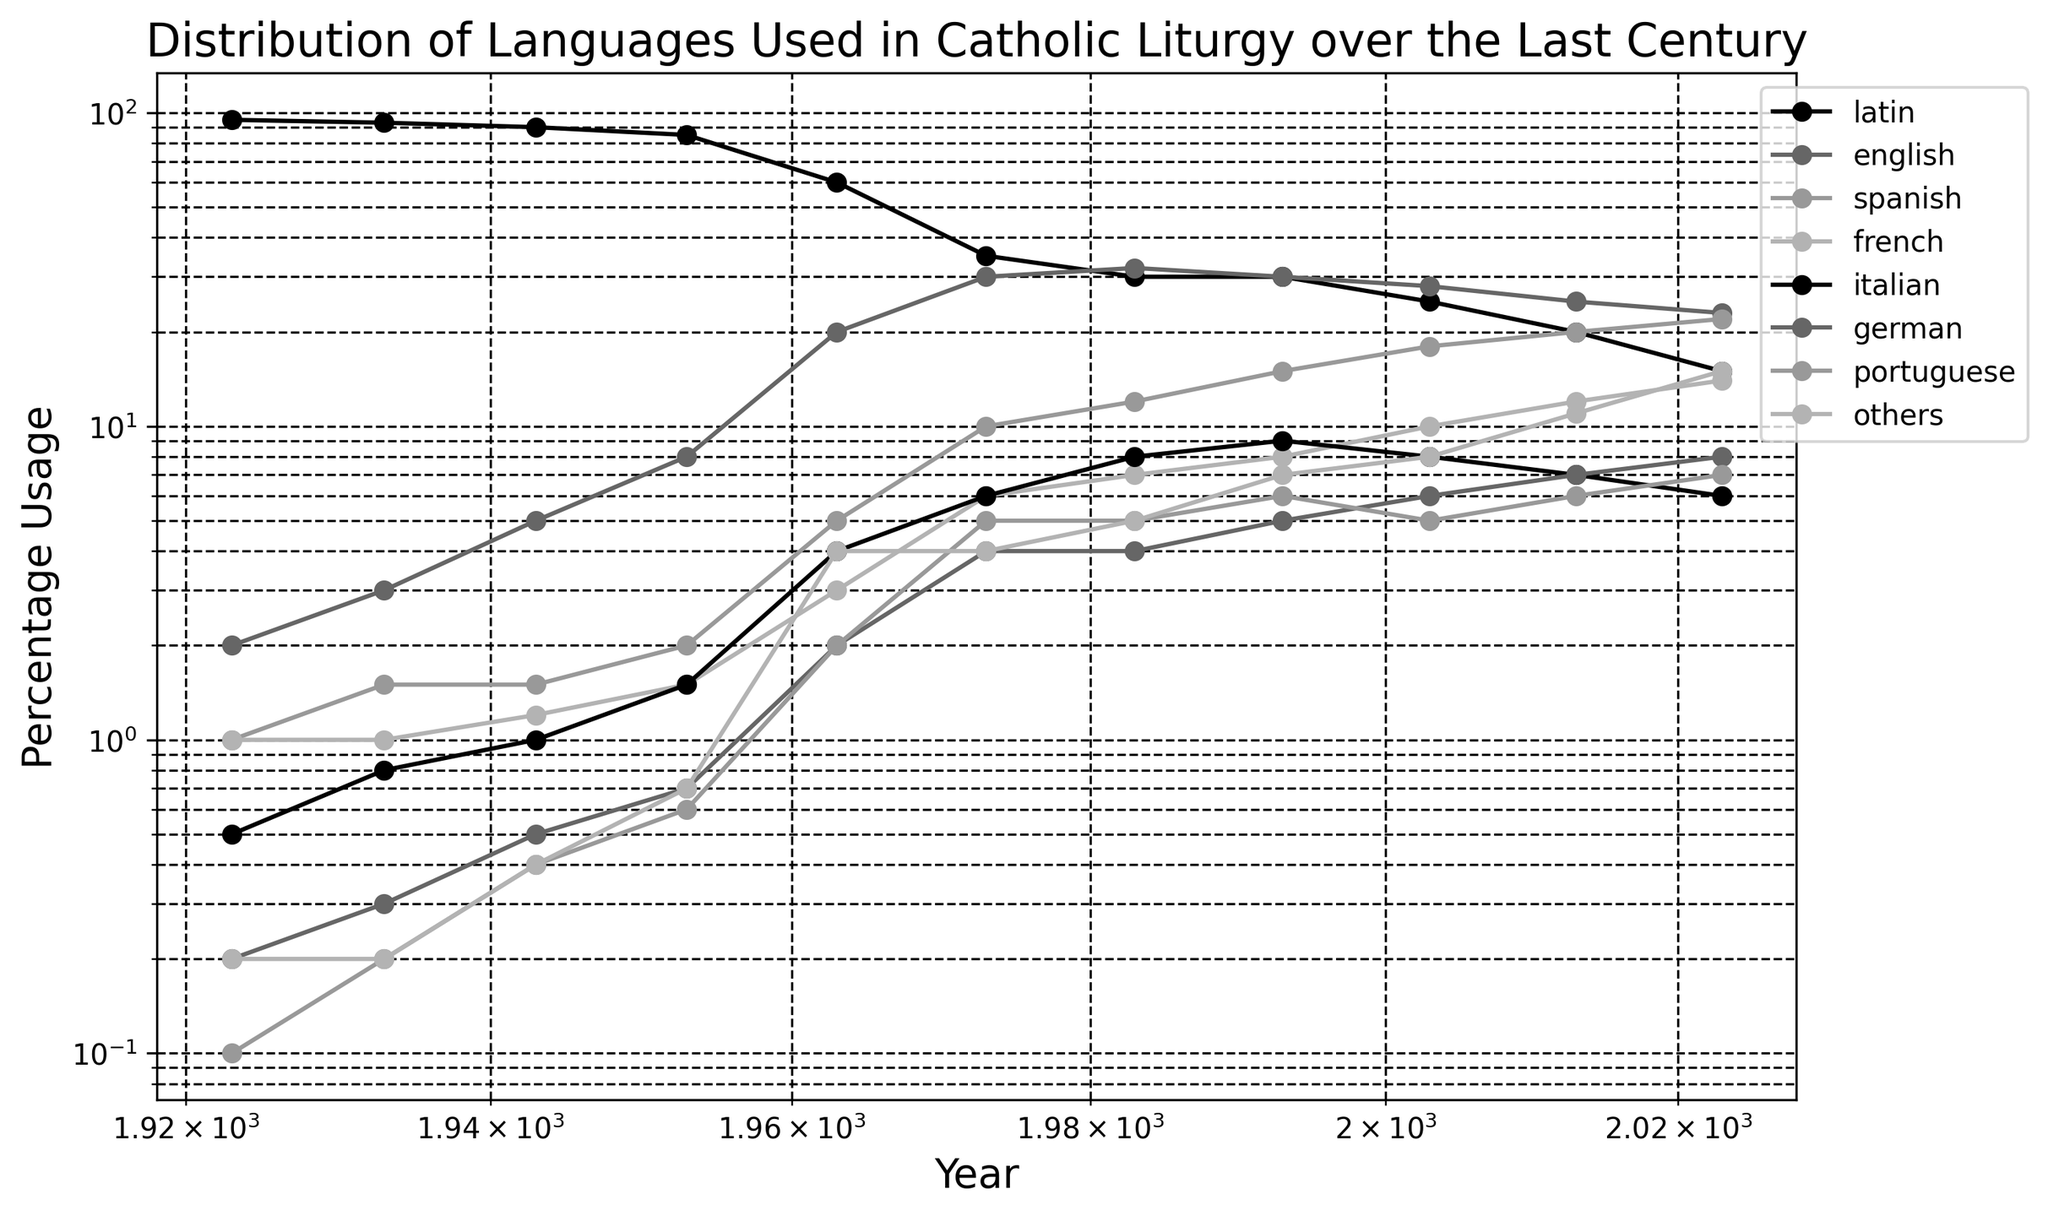what year did the usage of Latin drop to 60%? To find when the usage of Latin dropped to 60%, locate the intersection of the 'latin' line with the 60% value on the y-axis. This occurs in the year 1963.
Answer: 1963 Which two languages had equal usage percentages in the year 1983? Check the figure for 1983 and identify languages with the same vertical position. English and Spanish both had 12% usage in 1983.
Answer: English and Spanish How has the usage of the Italian language changed from 1943 to 2023? Locate the 'italian' line at 1943, showing 1%, and follow to 2023, indicating 6%. Calculate the change by subtracting 1% from 6%.
Answer: Increased by 5% In which year did English usage surpass Latin? Find the year where the 'english' line first rises above the 'latin' line. This occurs in 1973, where English is at 30% and Latin is below 35%.
Answer: 1973 Which language had the highest percentage in 1993? In 1993, identify the language with the highest point on the graph. Latin, English, and Spanish are all at approximately 30%, making them the highest.
Answer: Latin, English, and Spanish What's the total percentage of Spanish usage over the century? Sum the percentages of Spanish usage across all years: 1 + 1.5 + 1.5 + 2 + 5 + 10 + 12 + 15 + 18 + 20 + 22 = 108.
Answer: 108 What is the average usage of French from 1933 to 1963? Add the usage percentages of French from 1933, 1943, 1953, and 1963, and divide by the number of years: (1 + 1.2 + 1.5 + 3)/4 = 1.675.
Answer: 1.675 Which language had a continuous increase in usage from 1983 to 2023? Check the graph for languages that show consistent upward trends from 1983 to 2023. German shows a steady increase during these years.
Answer: German Compare the usage of Portuguese and others in the year 2023. In 2023, identify the percentage values for Portuguese (7%) and others (15%). 'Others' has a higher usage than Portuguese.
Answer: Others How many languages had more than 20% usage in 2013? Identify languages in 2013 with points above the 20% mark. English (25%) and Spanish (20%) meet this criterion.
Answer: Two 